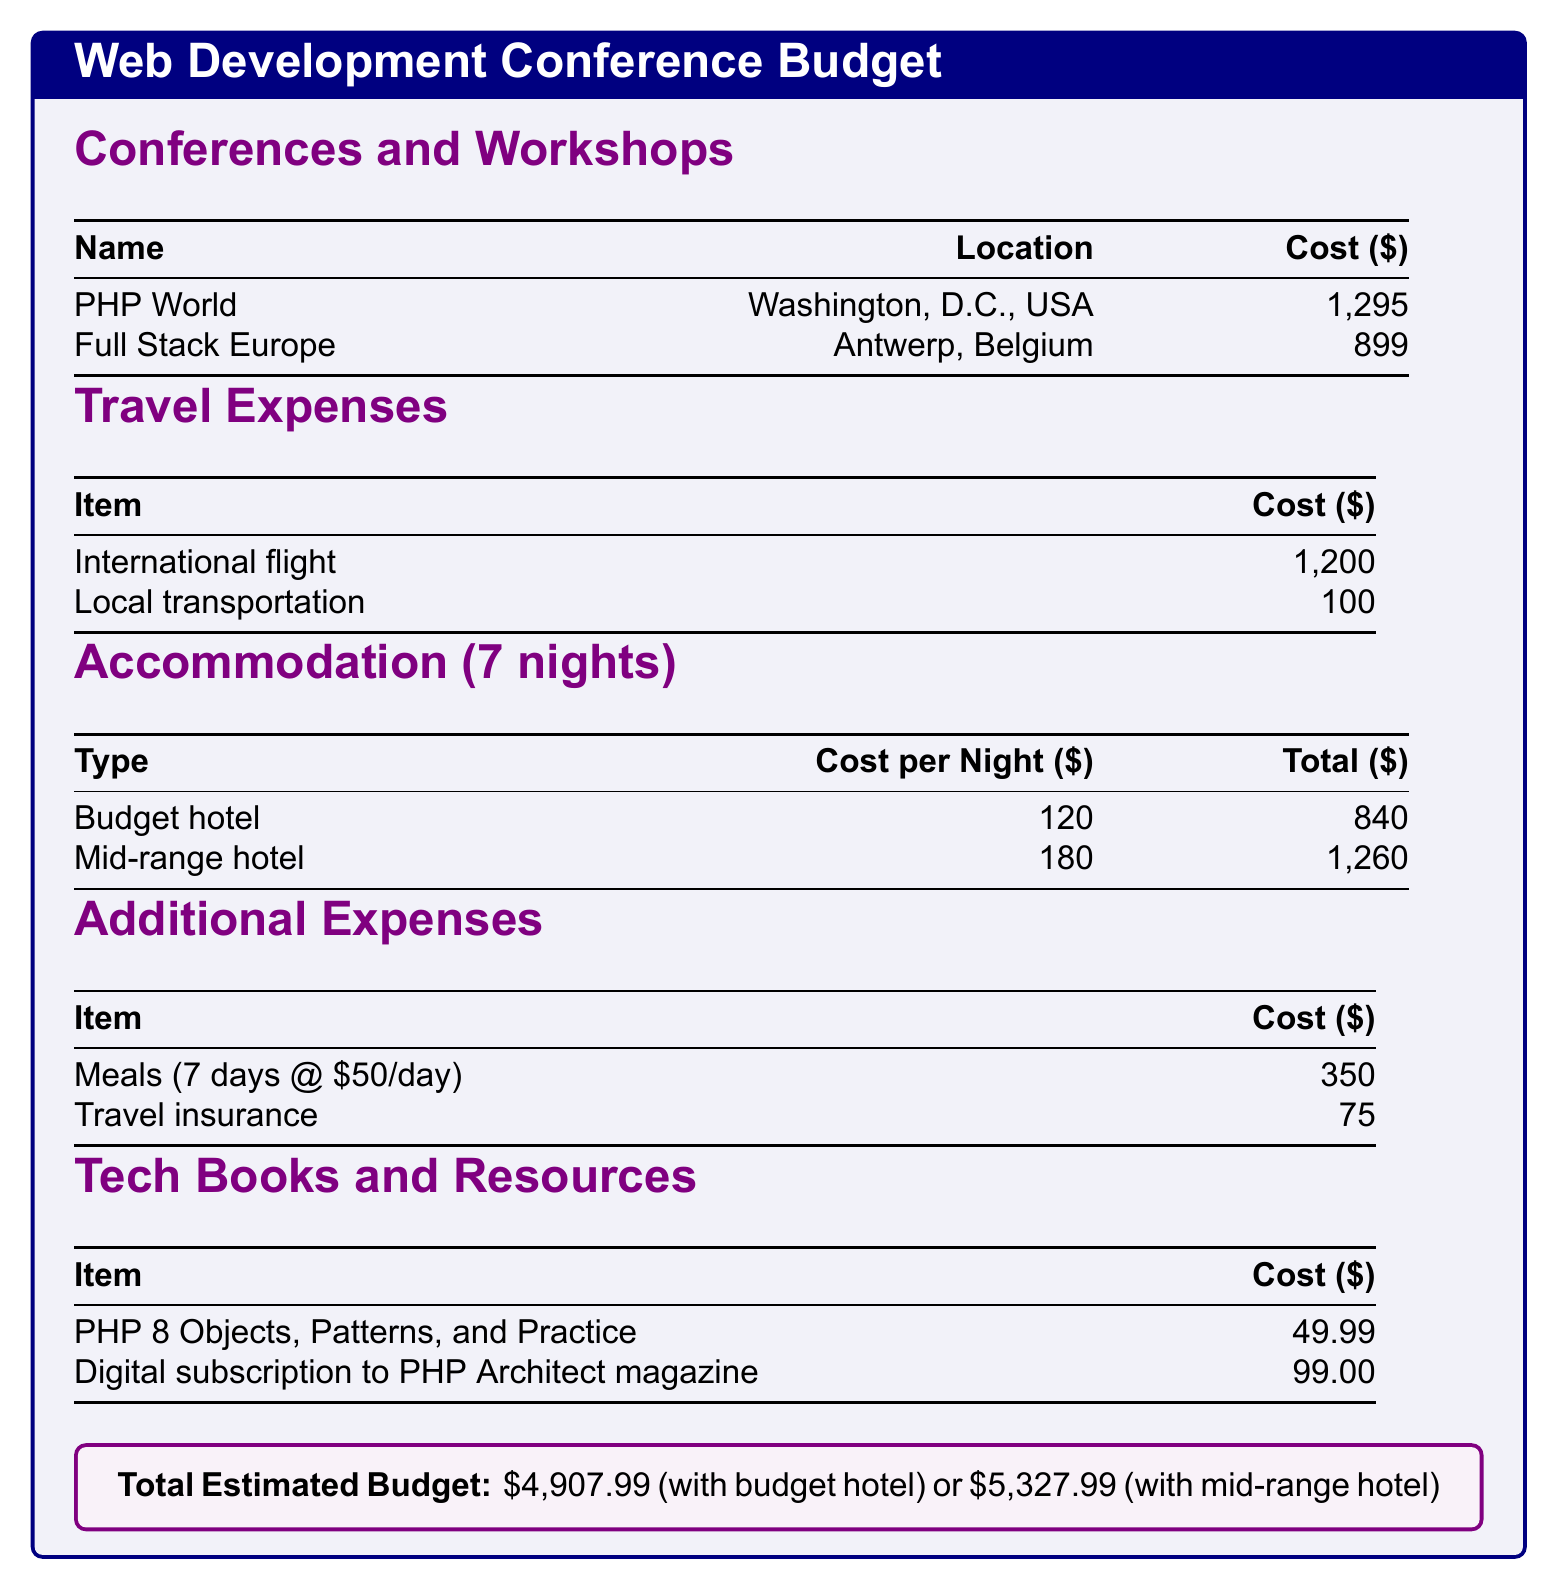What is the total estimated budget with a budget hotel? The total estimated budget with a budget hotel is given directly in the document.
Answer: $4,907.99 How much does the local transportation cost? The local transportation cost is specified in the travel expenses section.
Answer: $100 What is the cost of the PHP World conference? The cost for the PHP World conference is outlined in the conferences and workshops table.
Answer: $1,295 How many nights of accommodation are planned? The document states that 7 nights of accommodation are included in the budget.
Answer: 7 What is the cost of meals for the entire duration? The total cost of meals is calculated based on $50 per day for 7 days.
Answer: $350 What is the cost per night for a mid-range hotel? The cost per night for a mid-range hotel is provided in the accommodation section.
Answer: $180 How much are tech books and resources in total? The total for tech books and resources is derived from the individual costs listed in the document.
Answer: $148.99 What city is the Full Stack Europe conference held in? The location of the Full Stack Europe conference is specifically indicated in the conferences table.
Answer: Antwerp, Belgium What is the cost for travel insurance? The cost for travel insurance is mentioned in the additional expenses section of the document.
Answer: $75 